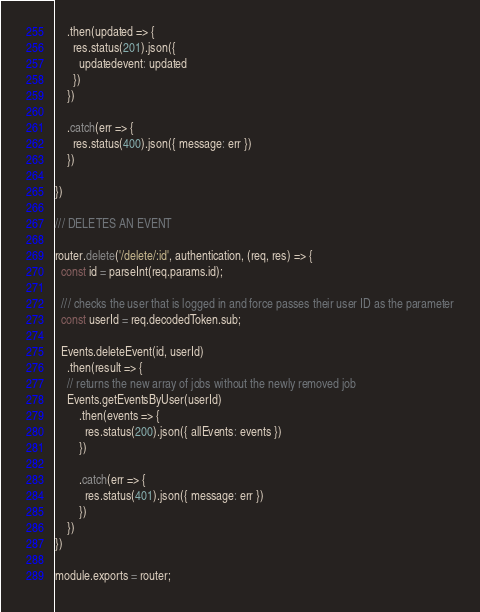Convert code to text. <code><loc_0><loc_0><loc_500><loc_500><_JavaScript_>    .then(updated => {
      res.status(201).json({ 
        updatedevent: updated
      })
    })

    .catch(err => {
      res.status(400).json({ message: err })
    })

})

/// DELETES AN EVENT

router.delete('/delete/:id', authentication, (req, res) => {
  const id = parseInt(req.params.id);

  /// checks the user that is logged in and force passes their user ID as the parameter
  const userId = req.decodedToken.sub;

  Events.deleteEvent(id, userId)
    .then(result => {
    // returns the new array of jobs without the newly removed job
    Events.getEventsByUser(userId)
        .then(events => {
          res.status(200).json({ allEvents: events })
        })

        .catch(err => {
          res.status(401).json({ message: err })
        })
    })
})

module.exports = router;
</code> 